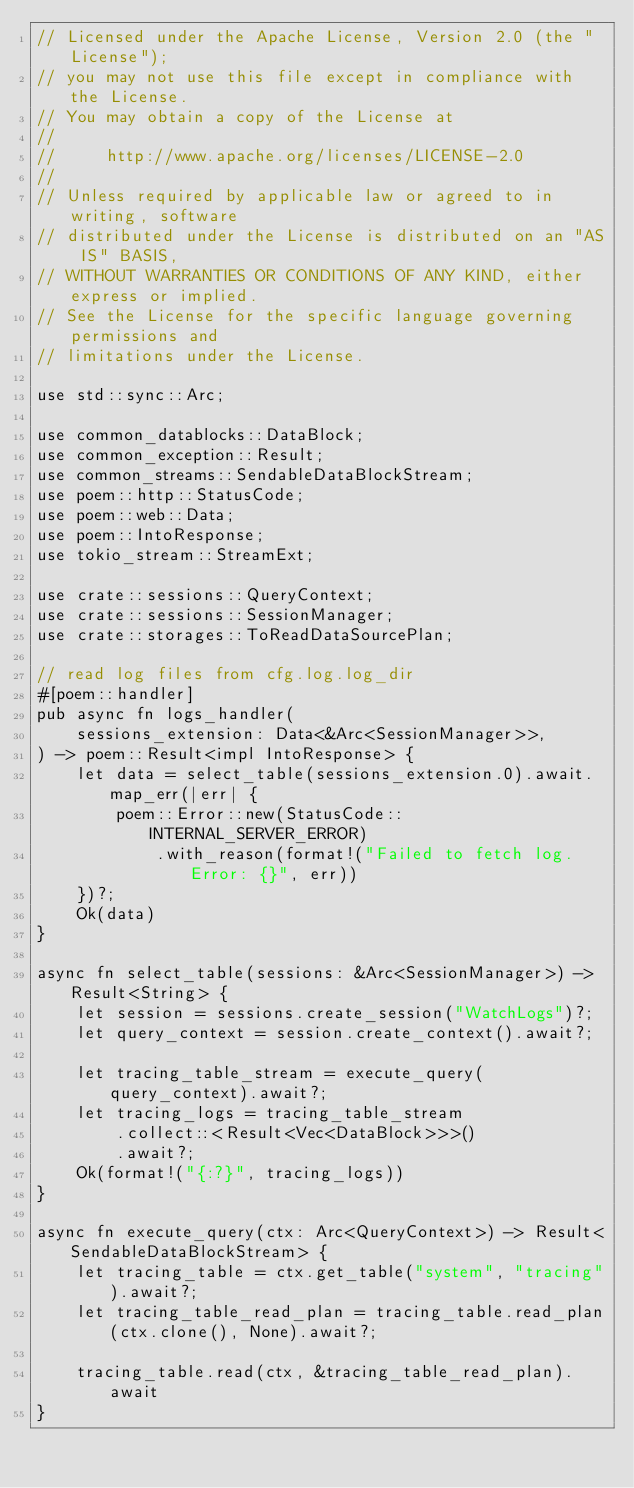Convert code to text. <code><loc_0><loc_0><loc_500><loc_500><_Rust_>// Licensed under the Apache License, Version 2.0 (the "License");
// you may not use this file except in compliance with the License.
// You may obtain a copy of the License at
//
//     http://www.apache.org/licenses/LICENSE-2.0
//
// Unless required by applicable law or agreed to in writing, software
// distributed under the License is distributed on an "AS IS" BASIS,
// WITHOUT WARRANTIES OR CONDITIONS OF ANY KIND, either express or implied.
// See the License for the specific language governing permissions and
// limitations under the License.

use std::sync::Arc;

use common_datablocks::DataBlock;
use common_exception::Result;
use common_streams::SendableDataBlockStream;
use poem::http::StatusCode;
use poem::web::Data;
use poem::IntoResponse;
use tokio_stream::StreamExt;

use crate::sessions::QueryContext;
use crate::sessions::SessionManager;
use crate::storages::ToReadDataSourcePlan;

// read log files from cfg.log.log_dir
#[poem::handler]
pub async fn logs_handler(
    sessions_extension: Data<&Arc<SessionManager>>,
) -> poem::Result<impl IntoResponse> {
    let data = select_table(sessions_extension.0).await.map_err(|err| {
        poem::Error::new(StatusCode::INTERNAL_SERVER_ERROR)
            .with_reason(format!("Failed to fetch log. Error: {}", err))
    })?;
    Ok(data)
}

async fn select_table(sessions: &Arc<SessionManager>) -> Result<String> {
    let session = sessions.create_session("WatchLogs")?;
    let query_context = session.create_context().await?;

    let tracing_table_stream = execute_query(query_context).await?;
    let tracing_logs = tracing_table_stream
        .collect::<Result<Vec<DataBlock>>>()
        .await?;
    Ok(format!("{:?}", tracing_logs))
}

async fn execute_query(ctx: Arc<QueryContext>) -> Result<SendableDataBlockStream> {
    let tracing_table = ctx.get_table("system", "tracing").await?;
    let tracing_table_read_plan = tracing_table.read_plan(ctx.clone(), None).await?;

    tracing_table.read(ctx, &tracing_table_read_plan).await
}
</code> 